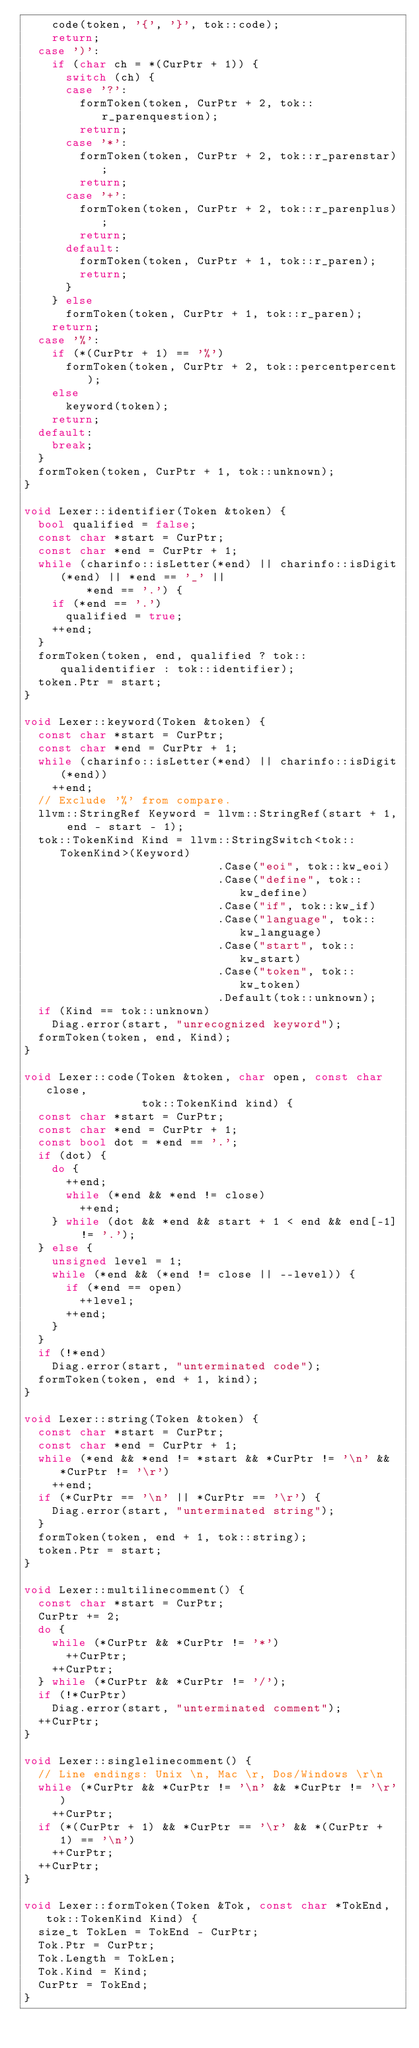<code> <loc_0><loc_0><loc_500><loc_500><_C++_>    code(token, '{', '}', tok::code);
    return;
  case ')':
    if (char ch = *(CurPtr + 1)) {
      switch (ch) {
      case '?':
        formToken(token, CurPtr + 2, tok::r_parenquestion);
        return;
      case '*':
        formToken(token, CurPtr + 2, tok::r_parenstar);
        return;
      case '+':
        formToken(token, CurPtr + 2, tok::r_parenplus);
        return;
      default:
        formToken(token, CurPtr + 1, tok::r_paren);
        return;
      }
    } else
      formToken(token, CurPtr + 1, tok::r_paren);
    return;
  case '%':
    if (*(CurPtr + 1) == '%')
      formToken(token, CurPtr + 2, tok::percentpercent);
    else
      keyword(token);
    return;
  default:
    break;
  }
  formToken(token, CurPtr + 1, tok::unknown);
}

void Lexer::identifier(Token &token) {
  bool qualified = false;
  const char *start = CurPtr;
  const char *end = CurPtr + 1;
  while (charinfo::isLetter(*end) || charinfo::isDigit(*end) || *end == '_' ||
         *end == '.') {
    if (*end == '.')
      qualified = true;
    ++end;
  }
  formToken(token, end, qualified ? tok::qualidentifier : tok::identifier);
  token.Ptr = start;
}

void Lexer::keyword(Token &token) {
  const char *start = CurPtr;
  const char *end = CurPtr + 1;
  while (charinfo::isLetter(*end) || charinfo::isDigit(*end))
    ++end;
  // Exclude '%' from compare.
  llvm::StringRef Keyword = llvm::StringRef(start + 1, end - start - 1);
  tok::TokenKind Kind = llvm::StringSwitch<tok::TokenKind>(Keyword)
                            .Case("eoi", tok::kw_eoi)
                            .Case("define", tok::kw_define)
                            .Case("if", tok::kw_if)
                            .Case("language", tok::kw_language)
                            .Case("start", tok::kw_start)
                            .Case("token", tok::kw_token)
                            .Default(tok::unknown);
  if (Kind == tok::unknown)
    Diag.error(start, "unrecognized keyword");
  formToken(token, end, Kind);
}

void Lexer::code(Token &token, char open, const char close,
                 tok::TokenKind kind) {
  const char *start = CurPtr;
  const char *end = CurPtr + 1;
  const bool dot = *end == '.';
  if (dot) {
    do {
      ++end;
      while (*end && *end != close)
        ++end;
    } while (dot && *end && start + 1 < end && end[-1] != '.');
  } else {
    unsigned level = 1;
    while (*end && (*end != close || --level)) {
      if (*end == open)
        ++level;
      ++end;
    }
  }
  if (!*end)
    Diag.error(start, "unterminated code");
  formToken(token, end + 1, kind);
}

void Lexer::string(Token &token) {
  const char *start = CurPtr;
  const char *end = CurPtr + 1;
  while (*end && *end != *start && *CurPtr != '\n' && *CurPtr != '\r')
    ++end;
  if (*CurPtr == '\n' || *CurPtr == '\r') {
    Diag.error(start, "unterminated string");
  }
  formToken(token, end + 1, tok::string);
  token.Ptr = start;
}

void Lexer::multilinecomment() {
  const char *start = CurPtr;
  CurPtr += 2;
  do {
    while (*CurPtr && *CurPtr != '*')
      ++CurPtr;
    ++CurPtr;
  } while (*CurPtr && *CurPtr != '/');
  if (!*CurPtr)
    Diag.error(start, "unterminated comment");
  ++CurPtr;
}

void Lexer::singlelinecomment() {
  // Line endings: Unix \n, Mac \r, Dos/Windows \r\n
  while (*CurPtr && *CurPtr != '\n' && *CurPtr != '\r')
    ++CurPtr;
  if (*(CurPtr + 1) && *CurPtr == '\r' && *(CurPtr + 1) == '\n')
    ++CurPtr;
  ++CurPtr;
}

void Lexer::formToken(Token &Tok, const char *TokEnd, tok::TokenKind Kind) {
  size_t TokLen = TokEnd - CurPtr;
  Tok.Ptr = CurPtr;
  Tok.Length = TokLen;
  Tok.Kind = Kind;
  CurPtr = TokEnd;
}</code> 